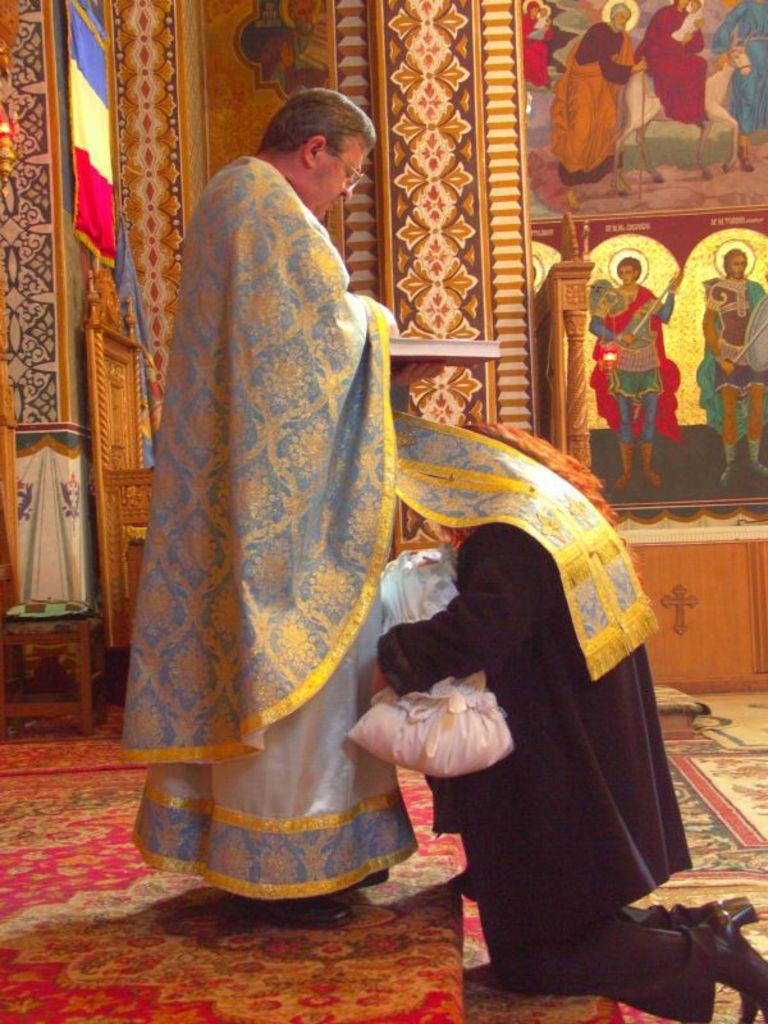What is the primary activity of the people in the image? The people in the image are on the ground, but the specific activity cannot be determined from the provided facts. What can be seen besides the people in the image? There is a book visible in the image. Can you describe the object in the image? The facts only mention that there is an object in the image, but its specific characteristics are not provided. What is visible in the background of the image? There are objects and a wall with designs in the background of the image. What type of powder is being used by the people in the image? There is no mention of powder in the image, so it cannot be determined if any is being used. 